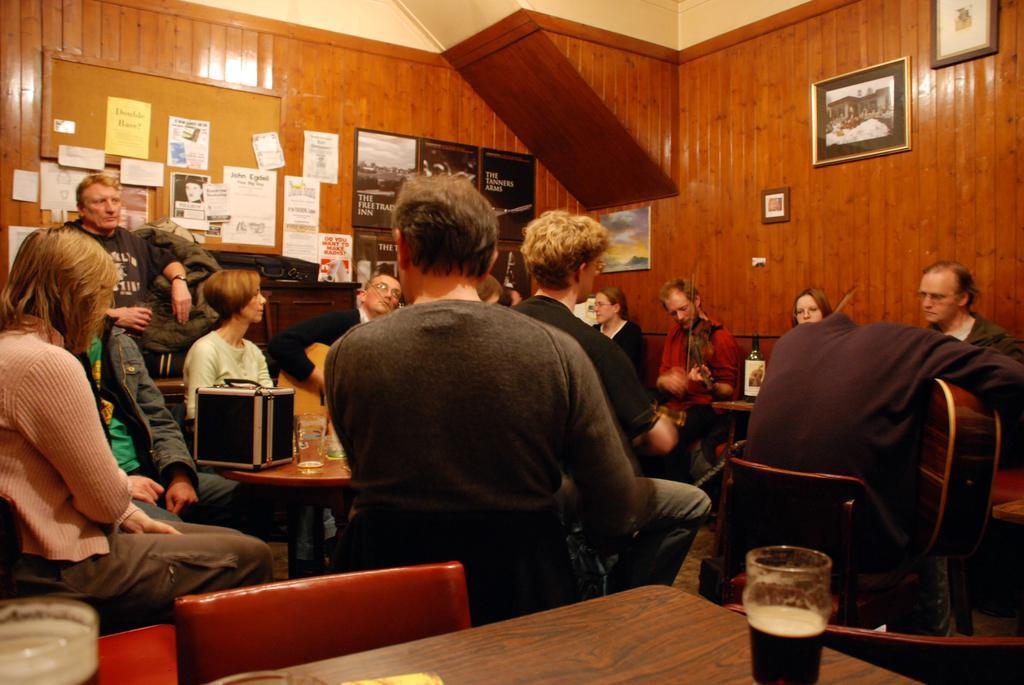Describe this image in one or two sentences. There is a group of people. They are sitting on a chairs. There is a table. There is a table,glass on a table. We can see in background posters,photo frame and cupboard. 